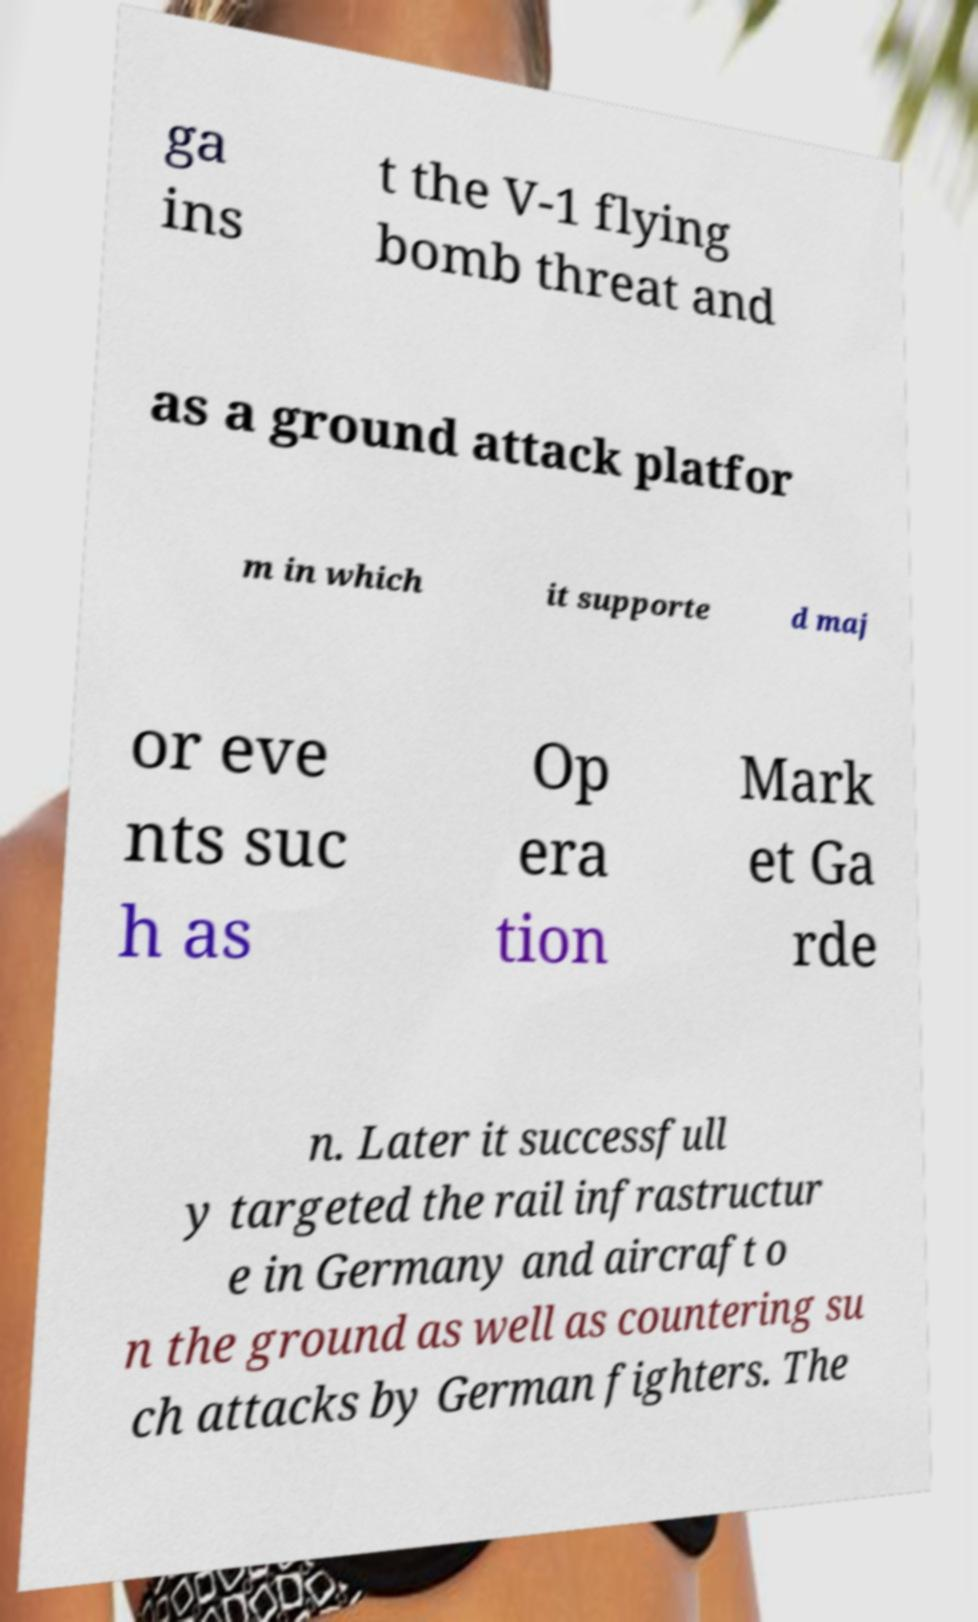Could you extract and type out the text from this image? ga ins t the V-1 flying bomb threat and as a ground attack platfor m in which it supporte d maj or eve nts suc h as Op era tion Mark et Ga rde n. Later it successfull y targeted the rail infrastructur e in Germany and aircraft o n the ground as well as countering su ch attacks by German fighters. The 